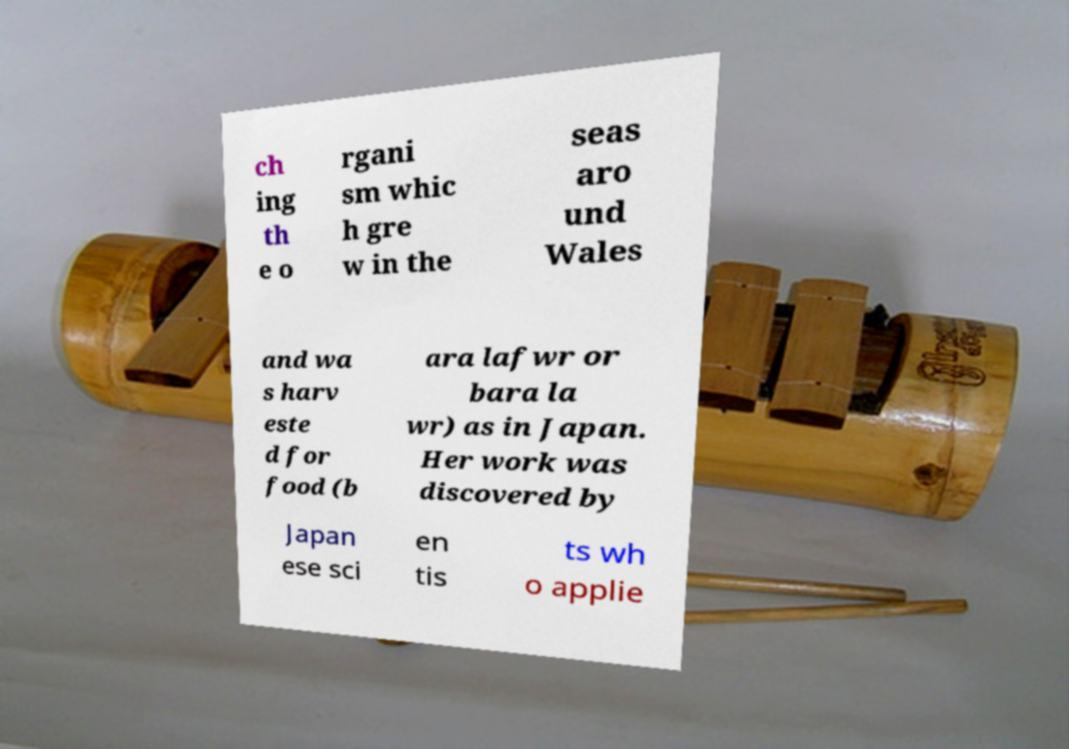I need the written content from this picture converted into text. Can you do that? ch ing th e o rgani sm whic h gre w in the seas aro und Wales and wa s harv este d for food (b ara lafwr or bara la wr) as in Japan. Her work was discovered by Japan ese sci en tis ts wh o applie 